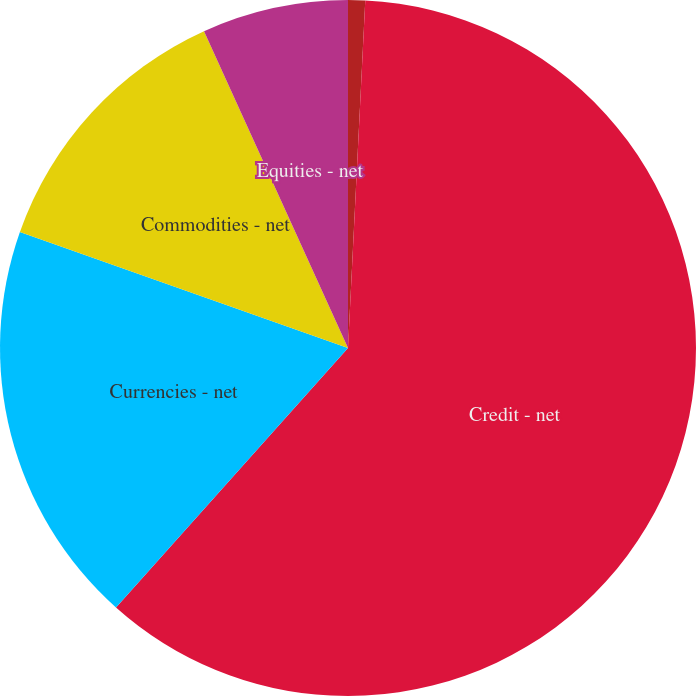Convert chart. <chart><loc_0><loc_0><loc_500><loc_500><pie_chart><fcel>Interest rates - net<fcel>Credit - net<fcel>Currencies - net<fcel>Commodities - net<fcel>Equities - net<nl><fcel>0.79%<fcel>60.83%<fcel>18.8%<fcel>12.8%<fcel>6.79%<nl></chart> 